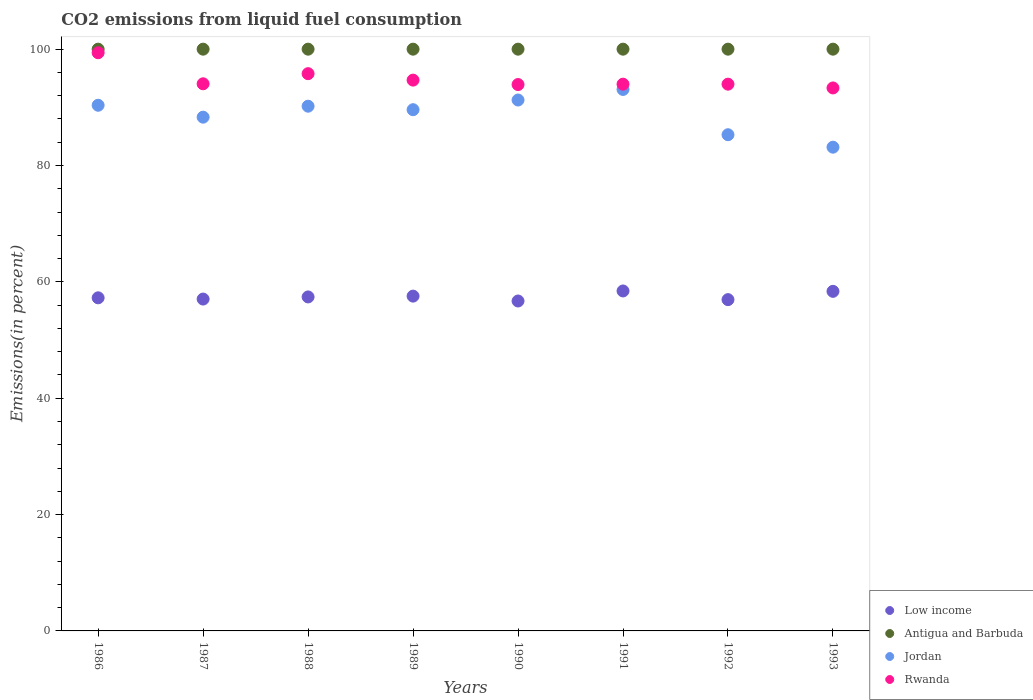What is the total CO2 emitted in Antigua and Barbuda in 1991?
Offer a terse response. 100. Across all years, what is the maximum total CO2 emitted in Antigua and Barbuda?
Give a very brief answer. 100. Across all years, what is the minimum total CO2 emitted in Jordan?
Offer a terse response. 83.15. In which year was the total CO2 emitted in Low income maximum?
Provide a succinct answer. 1991. What is the total total CO2 emitted in Rwanda in the graph?
Ensure brevity in your answer.  759.13. What is the difference between the total CO2 emitted in Antigua and Barbuda in 1992 and the total CO2 emitted in Low income in 1990?
Your answer should be very brief. 43.29. What is the average total CO2 emitted in Antigua and Barbuda per year?
Provide a short and direct response. 100. In the year 1993, what is the difference between the total CO2 emitted in Low income and total CO2 emitted in Antigua and Barbuda?
Provide a short and direct response. -41.63. In how many years, is the total CO2 emitted in Low income greater than 56 %?
Make the answer very short. 8. Is the total CO2 emitted in Antigua and Barbuda in 1987 less than that in 1993?
Give a very brief answer. No. Is the difference between the total CO2 emitted in Low income in 1986 and 1987 greater than the difference between the total CO2 emitted in Antigua and Barbuda in 1986 and 1987?
Offer a very short reply. Yes. What is the difference between the highest and the second highest total CO2 emitted in Jordan?
Your answer should be very brief. 1.82. What is the difference between the highest and the lowest total CO2 emitted in Jordan?
Your response must be concise. 9.92. In how many years, is the total CO2 emitted in Antigua and Barbuda greater than the average total CO2 emitted in Antigua and Barbuda taken over all years?
Make the answer very short. 0. Does the total CO2 emitted in Rwanda monotonically increase over the years?
Your answer should be compact. No. Is the total CO2 emitted in Jordan strictly less than the total CO2 emitted in Low income over the years?
Keep it short and to the point. No. How many dotlines are there?
Ensure brevity in your answer.  4. Are the values on the major ticks of Y-axis written in scientific E-notation?
Make the answer very short. No. Does the graph contain any zero values?
Ensure brevity in your answer.  No. Does the graph contain grids?
Provide a succinct answer. No. What is the title of the graph?
Your answer should be very brief. CO2 emissions from liquid fuel consumption. Does "Solomon Islands" appear as one of the legend labels in the graph?
Make the answer very short. No. What is the label or title of the X-axis?
Keep it short and to the point. Years. What is the label or title of the Y-axis?
Offer a terse response. Emissions(in percent). What is the Emissions(in percent) in Low income in 1986?
Your answer should be compact. 57.26. What is the Emissions(in percent) of Antigua and Barbuda in 1986?
Provide a short and direct response. 100. What is the Emissions(in percent) in Jordan in 1986?
Your answer should be very brief. 90.36. What is the Emissions(in percent) in Rwanda in 1986?
Make the answer very short. 99.39. What is the Emissions(in percent) of Low income in 1987?
Provide a succinct answer. 57.05. What is the Emissions(in percent) of Jordan in 1987?
Your answer should be compact. 88.31. What is the Emissions(in percent) of Rwanda in 1987?
Give a very brief answer. 94.05. What is the Emissions(in percent) of Low income in 1988?
Give a very brief answer. 57.41. What is the Emissions(in percent) of Jordan in 1988?
Your response must be concise. 90.2. What is the Emissions(in percent) of Rwanda in 1988?
Give a very brief answer. 95.79. What is the Emissions(in percent) of Low income in 1989?
Offer a very short reply. 57.55. What is the Emissions(in percent) of Antigua and Barbuda in 1989?
Keep it short and to the point. 100. What is the Emissions(in percent) of Jordan in 1989?
Provide a succinct answer. 89.59. What is the Emissions(in percent) of Rwanda in 1989?
Your response must be concise. 94.68. What is the Emissions(in percent) of Low income in 1990?
Your response must be concise. 56.71. What is the Emissions(in percent) in Jordan in 1990?
Give a very brief answer. 91.26. What is the Emissions(in percent) of Rwanda in 1990?
Offer a terse response. 93.92. What is the Emissions(in percent) in Low income in 1991?
Your answer should be compact. 58.44. What is the Emissions(in percent) in Antigua and Barbuda in 1991?
Offer a terse response. 100. What is the Emissions(in percent) of Jordan in 1991?
Make the answer very short. 93.08. What is the Emissions(in percent) in Rwanda in 1991?
Your answer should be very brief. 93.98. What is the Emissions(in percent) in Low income in 1992?
Your answer should be very brief. 56.95. What is the Emissions(in percent) of Jordan in 1992?
Provide a succinct answer. 85.29. What is the Emissions(in percent) in Rwanda in 1992?
Give a very brief answer. 93.98. What is the Emissions(in percent) of Low income in 1993?
Give a very brief answer. 58.37. What is the Emissions(in percent) in Jordan in 1993?
Ensure brevity in your answer.  83.15. What is the Emissions(in percent) of Rwanda in 1993?
Your answer should be compact. 93.33. Across all years, what is the maximum Emissions(in percent) of Low income?
Give a very brief answer. 58.44. Across all years, what is the maximum Emissions(in percent) in Antigua and Barbuda?
Provide a short and direct response. 100. Across all years, what is the maximum Emissions(in percent) in Jordan?
Keep it short and to the point. 93.08. Across all years, what is the maximum Emissions(in percent) of Rwanda?
Your answer should be very brief. 99.39. Across all years, what is the minimum Emissions(in percent) of Low income?
Keep it short and to the point. 56.71. Across all years, what is the minimum Emissions(in percent) in Antigua and Barbuda?
Your answer should be very brief. 100. Across all years, what is the minimum Emissions(in percent) in Jordan?
Your answer should be compact. 83.15. Across all years, what is the minimum Emissions(in percent) of Rwanda?
Make the answer very short. 93.33. What is the total Emissions(in percent) of Low income in the graph?
Make the answer very short. 459.73. What is the total Emissions(in percent) of Antigua and Barbuda in the graph?
Your answer should be very brief. 800. What is the total Emissions(in percent) of Jordan in the graph?
Your answer should be compact. 711.24. What is the total Emissions(in percent) in Rwanda in the graph?
Your answer should be very brief. 759.13. What is the difference between the Emissions(in percent) in Low income in 1986 and that in 1987?
Give a very brief answer. 0.21. What is the difference between the Emissions(in percent) of Antigua and Barbuda in 1986 and that in 1987?
Your response must be concise. 0. What is the difference between the Emissions(in percent) of Jordan in 1986 and that in 1987?
Give a very brief answer. 2.05. What is the difference between the Emissions(in percent) of Rwanda in 1986 and that in 1987?
Offer a terse response. 5.34. What is the difference between the Emissions(in percent) of Low income in 1986 and that in 1988?
Your response must be concise. -0.15. What is the difference between the Emissions(in percent) of Antigua and Barbuda in 1986 and that in 1988?
Provide a succinct answer. 0. What is the difference between the Emissions(in percent) of Jordan in 1986 and that in 1988?
Make the answer very short. 0.16. What is the difference between the Emissions(in percent) in Rwanda in 1986 and that in 1988?
Make the answer very short. 3.6. What is the difference between the Emissions(in percent) in Low income in 1986 and that in 1989?
Your answer should be compact. -0.29. What is the difference between the Emissions(in percent) in Antigua and Barbuda in 1986 and that in 1989?
Your response must be concise. 0. What is the difference between the Emissions(in percent) of Jordan in 1986 and that in 1989?
Your answer should be compact. 0.76. What is the difference between the Emissions(in percent) in Rwanda in 1986 and that in 1989?
Keep it short and to the point. 4.71. What is the difference between the Emissions(in percent) in Low income in 1986 and that in 1990?
Offer a terse response. 0.55. What is the difference between the Emissions(in percent) of Antigua and Barbuda in 1986 and that in 1990?
Make the answer very short. 0. What is the difference between the Emissions(in percent) of Jordan in 1986 and that in 1990?
Keep it short and to the point. -0.9. What is the difference between the Emissions(in percent) in Rwanda in 1986 and that in 1990?
Provide a succinct answer. 5.47. What is the difference between the Emissions(in percent) of Low income in 1986 and that in 1991?
Your response must be concise. -1.18. What is the difference between the Emissions(in percent) in Jordan in 1986 and that in 1991?
Offer a very short reply. -2.72. What is the difference between the Emissions(in percent) of Rwanda in 1986 and that in 1991?
Keep it short and to the point. 5.4. What is the difference between the Emissions(in percent) in Low income in 1986 and that in 1992?
Make the answer very short. 0.31. What is the difference between the Emissions(in percent) in Antigua and Barbuda in 1986 and that in 1992?
Your answer should be compact. 0. What is the difference between the Emissions(in percent) of Jordan in 1986 and that in 1992?
Make the answer very short. 5.07. What is the difference between the Emissions(in percent) of Rwanda in 1986 and that in 1992?
Offer a very short reply. 5.4. What is the difference between the Emissions(in percent) of Low income in 1986 and that in 1993?
Ensure brevity in your answer.  -1.11. What is the difference between the Emissions(in percent) in Jordan in 1986 and that in 1993?
Keep it short and to the point. 7.21. What is the difference between the Emissions(in percent) in Rwanda in 1986 and that in 1993?
Ensure brevity in your answer.  6.05. What is the difference between the Emissions(in percent) of Low income in 1987 and that in 1988?
Offer a very short reply. -0.37. What is the difference between the Emissions(in percent) in Jordan in 1987 and that in 1988?
Ensure brevity in your answer.  -1.89. What is the difference between the Emissions(in percent) in Rwanda in 1987 and that in 1988?
Ensure brevity in your answer.  -1.74. What is the difference between the Emissions(in percent) in Low income in 1987 and that in 1989?
Your answer should be compact. -0.51. What is the difference between the Emissions(in percent) of Antigua and Barbuda in 1987 and that in 1989?
Your response must be concise. 0. What is the difference between the Emissions(in percent) in Jordan in 1987 and that in 1989?
Your answer should be compact. -1.28. What is the difference between the Emissions(in percent) of Rwanda in 1987 and that in 1989?
Your answer should be compact. -0.63. What is the difference between the Emissions(in percent) in Low income in 1987 and that in 1990?
Give a very brief answer. 0.33. What is the difference between the Emissions(in percent) in Jordan in 1987 and that in 1990?
Make the answer very short. -2.95. What is the difference between the Emissions(in percent) in Rwanda in 1987 and that in 1990?
Give a very brief answer. 0.13. What is the difference between the Emissions(in percent) in Low income in 1987 and that in 1991?
Keep it short and to the point. -1.39. What is the difference between the Emissions(in percent) in Antigua and Barbuda in 1987 and that in 1991?
Provide a short and direct response. 0. What is the difference between the Emissions(in percent) in Jordan in 1987 and that in 1991?
Your answer should be very brief. -4.77. What is the difference between the Emissions(in percent) of Rwanda in 1987 and that in 1991?
Make the answer very short. 0.06. What is the difference between the Emissions(in percent) in Low income in 1987 and that in 1992?
Give a very brief answer. 0.1. What is the difference between the Emissions(in percent) in Jordan in 1987 and that in 1992?
Your answer should be very brief. 3.02. What is the difference between the Emissions(in percent) of Rwanda in 1987 and that in 1992?
Provide a short and direct response. 0.06. What is the difference between the Emissions(in percent) of Low income in 1987 and that in 1993?
Provide a short and direct response. -1.33. What is the difference between the Emissions(in percent) of Jordan in 1987 and that in 1993?
Make the answer very short. 5.16. What is the difference between the Emissions(in percent) of Rwanda in 1987 and that in 1993?
Your response must be concise. 0.71. What is the difference between the Emissions(in percent) in Low income in 1988 and that in 1989?
Your response must be concise. -0.14. What is the difference between the Emissions(in percent) in Jordan in 1988 and that in 1989?
Provide a short and direct response. 0.6. What is the difference between the Emissions(in percent) in Rwanda in 1988 and that in 1989?
Give a very brief answer. 1.11. What is the difference between the Emissions(in percent) of Low income in 1988 and that in 1990?
Keep it short and to the point. 0.7. What is the difference between the Emissions(in percent) in Antigua and Barbuda in 1988 and that in 1990?
Your answer should be compact. 0. What is the difference between the Emissions(in percent) of Jordan in 1988 and that in 1990?
Provide a short and direct response. -1.06. What is the difference between the Emissions(in percent) in Rwanda in 1988 and that in 1990?
Provide a short and direct response. 1.87. What is the difference between the Emissions(in percent) in Low income in 1988 and that in 1991?
Your answer should be very brief. -1.03. What is the difference between the Emissions(in percent) in Antigua and Barbuda in 1988 and that in 1991?
Ensure brevity in your answer.  0. What is the difference between the Emissions(in percent) of Jordan in 1988 and that in 1991?
Provide a succinct answer. -2.88. What is the difference between the Emissions(in percent) in Rwanda in 1988 and that in 1991?
Offer a terse response. 1.8. What is the difference between the Emissions(in percent) of Low income in 1988 and that in 1992?
Your answer should be very brief. 0.47. What is the difference between the Emissions(in percent) in Jordan in 1988 and that in 1992?
Provide a short and direct response. 4.91. What is the difference between the Emissions(in percent) in Rwanda in 1988 and that in 1992?
Keep it short and to the point. 1.8. What is the difference between the Emissions(in percent) of Low income in 1988 and that in 1993?
Your response must be concise. -0.96. What is the difference between the Emissions(in percent) in Antigua and Barbuda in 1988 and that in 1993?
Your answer should be very brief. 0. What is the difference between the Emissions(in percent) of Jordan in 1988 and that in 1993?
Make the answer very short. 7.05. What is the difference between the Emissions(in percent) of Rwanda in 1988 and that in 1993?
Keep it short and to the point. 2.46. What is the difference between the Emissions(in percent) of Low income in 1989 and that in 1990?
Keep it short and to the point. 0.84. What is the difference between the Emissions(in percent) in Jordan in 1989 and that in 1990?
Your answer should be compact. -1.66. What is the difference between the Emissions(in percent) of Rwanda in 1989 and that in 1990?
Your response must be concise. 0.76. What is the difference between the Emissions(in percent) in Low income in 1989 and that in 1991?
Keep it short and to the point. -0.89. What is the difference between the Emissions(in percent) in Jordan in 1989 and that in 1991?
Ensure brevity in your answer.  -3.48. What is the difference between the Emissions(in percent) in Rwanda in 1989 and that in 1991?
Keep it short and to the point. 0.7. What is the difference between the Emissions(in percent) in Low income in 1989 and that in 1992?
Provide a short and direct response. 0.6. What is the difference between the Emissions(in percent) in Antigua and Barbuda in 1989 and that in 1992?
Provide a succinct answer. 0. What is the difference between the Emissions(in percent) in Jordan in 1989 and that in 1992?
Provide a succinct answer. 4.3. What is the difference between the Emissions(in percent) of Rwanda in 1989 and that in 1992?
Your answer should be compact. 0.7. What is the difference between the Emissions(in percent) of Low income in 1989 and that in 1993?
Make the answer very short. -0.82. What is the difference between the Emissions(in percent) in Antigua and Barbuda in 1989 and that in 1993?
Ensure brevity in your answer.  0. What is the difference between the Emissions(in percent) in Jordan in 1989 and that in 1993?
Your response must be concise. 6.44. What is the difference between the Emissions(in percent) in Rwanda in 1989 and that in 1993?
Your answer should be very brief. 1.35. What is the difference between the Emissions(in percent) of Low income in 1990 and that in 1991?
Make the answer very short. -1.73. What is the difference between the Emissions(in percent) of Antigua and Barbuda in 1990 and that in 1991?
Your answer should be compact. 0. What is the difference between the Emissions(in percent) in Jordan in 1990 and that in 1991?
Your answer should be compact. -1.82. What is the difference between the Emissions(in percent) of Rwanda in 1990 and that in 1991?
Your answer should be very brief. -0.07. What is the difference between the Emissions(in percent) of Low income in 1990 and that in 1992?
Give a very brief answer. -0.23. What is the difference between the Emissions(in percent) in Antigua and Barbuda in 1990 and that in 1992?
Ensure brevity in your answer.  0. What is the difference between the Emissions(in percent) in Jordan in 1990 and that in 1992?
Provide a succinct answer. 5.97. What is the difference between the Emissions(in percent) in Rwanda in 1990 and that in 1992?
Provide a short and direct response. -0.07. What is the difference between the Emissions(in percent) of Low income in 1990 and that in 1993?
Your response must be concise. -1.66. What is the difference between the Emissions(in percent) in Antigua and Barbuda in 1990 and that in 1993?
Ensure brevity in your answer.  0. What is the difference between the Emissions(in percent) of Jordan in 1990 and that in 1993?
Your answer should be compact. 8.11. What is the difference between the Emissions(in percent) of Rwanda in 1990 and that in 1993?
Keep it short and to the point. 0.59. What is the difference between the Emissions(in percent) in Low income in 1991 and that in 1992?
Provide a short and direct response. 1.49. What is the difference between the Emissions(in percent) of Antigua and Barbuda in 1991 and that in 1992?
Ensure brevity in your answer.  0. What is the difference between the Emissions(in percent) in Jordan in 1991 and that in 1992?
Offer a very short reply. 7.78. What is the difference between the Emissions(in percent) in Rwanda in 1991 and that in 1992?
Ensure brevity in your answer.  0. What is the difference between the Emissions(in percent) of Low income in 1991 and that in 1993?
Give a very brief answer. 0.07. What is the difference between the Emissions(in percent) in Antigua and Barbuda in 1991 and that in 1993?
Your answer should be compact. 0. What is the difference between the Emissions(in percent) of Jordan in 1991 and that in 1993?
Your response must be concise. 9.92. What is the difference between the Emissions(in percent) of Rwanda in 1991 and that in 1993?
Make the answer very short. 0.65. What is the difference between the Emissions(in percent) in Low income in 1992 and that in 1993?
Your answer should be very brief. -1.43. What is the difference between the Emissions(in percent) in Jordan in 1992 and that in 1993?
Provide a short and direct response. 2.14. What is the difference between the Emissions(in percent) of Rwanda in 1992 and that in 1993?
Your answer should be very brief. 0.65. What is the difference between the Emissions(in percent) of Low income in 1986 and the Emissions(in percent) of Antigua and Barbuda in 1987?
Ensure brevity in your answer.  -42.74. What is the difference between the Emissions(in percent) of Low income in 1986 and the Emissions(in percent) of Jordan in 1987?
Offer a terse response. -31.05. What is the difference between the Emissions(in percent) of Low income in 1986 and the Emissions(in percent) of Rwanda in 1987?
Provide a short and direct response. -36.79. What is the difference between the Emissions(in percent) in Antigua and Barbuda in 1986 and the Emissions(in percent) in Jordan in 1987?
Make the answer very short. 11.69. What is the difference between the Emissions(in percent) of Antigua and Barbuda in 1986 and the Emissions(in percent) of Rwanda in 1987?
Provide a short and direct response. 5.95. What is the difference between the Emissions(in percent) in Jordan in 1986 and the Emissions(in percent) in Rwanda in 1987?
Your response must be concise. -3.69. What is the difference between the Emissions(in percent) of Low income in 1986 and the Emissions(in percent) of Antigua and Barbuda in 1988?
Provide a short and direct response. -42.74. What is the difference between the Emissions(in percent) of Low income in 1986 and the Emissions(in percent) of Jordan in 1988?
Your answer should be compact. -32.94. What is the difference between the Emissions(in percent) of Low income in 1986 and the Emissions(in percent) of Rwanda in 1988?
Your answer should be very brief. -38.53. What is the difference between the Emissions(in percent) in Antigua and Barbuda in 1986 and the Emissions(in percent) in Jordan in 1988?
Your answer should be very brief. 9.8. What is the difference between the Emissions(in percent) of Antigua and Barbuda in 1986 and the Emissions(in percent) of Rwanda in 1988?
Offer a terse response. 4.21. What is the difference between the Emissions(in percent) of Jordan in 1986 and the Emissions(in percent) of Rwanda in 1988?
Your answer should be compact. -5.43. What is the difference between the Emissions(in percent) of Low income in 1986 and the Emissions(in percent) of Antigua and Barbuda in 1989?
Offer a very short reply. -42.74. What is the difference between the Emissions(in percent) of Low income in 1986 and the Emissions(in percent) of Jordan in 1989?
Your answer should be compact. -32.34. What is the difference between the Emissions(in percent) in Low income in 1986 and the Emissions(in percent) in Rwanda in 1989?
Provide a succinct answer. -37.42. What is the difference between the Emissions(in percent) in Antigua and Barbuda in 1986 and the Emissions(in percent) in Jordan in 1989?
Provide a succinct answer. 10.41. What is the difference between the Emissions(in percent) of Antigua and Barbuda in 1986 and the Emissions(in percent) of Rwanda in 1989?
Offer a very short reply. 5.32. What is the difference between the Emissions(in percent) in Jordan in 1986 and the Emissions(in percent) in Rwanda in 1989?
Give a very brief answer. -4.32. What is the difference between the Emissions(in percent) of Low income in 1986 and the Emissions(in percent) of Antigua and Barbuda in 1990?
Your answer should be compact. -42.74. What is the difference between the Emissions(in percent) in Low income in 1986 and the Emissions(in percent) in Jordan in 1990?
Your response must be concise. -34. What is the difference between the Emissions(in percent) of Low income in 1986 and the Emissions(in percent) of Rwanda in 1990?
Your answer should be compact. -36.66. What is the difference between the Emissions(in percent) of Antigua and Barbuda in 1986 and the Emissions(in percent) of Jordan in 1990?
Give a very brief answer. 8.74. What is the difference between the Emissions(in percent) of Antigua and Barbuda in 1986 and the Emissions(in percent) of Rwanda in 1990?
Your response must be concise. 6.08. What is the difference between the Emissions(in percent) of Jordan in 1986 and the Emissions(in percent) of Rwanda in 1990?
Provide a short and direct response. -3.56. What is the difference between the Emissions(in percent) of Low income in 1986 and the Emissions(in percent) of Antigua and Barbuda in 1991?
Provide a short and direct response. -42.74. What is the difference between the Emissions(in percent) in Low income in 1986 and the Emissions(in percent) in Jordan in 1991?
Offer a terse response. -35.82. What is the difference between the Emissions(in percent) in Low income in 1986 and the Emissions(in percent) in Rwanda in 1991?
Provide a short and direct response. -36.73. What is the difference between the Emissions(in percent) of Antigua and Barbuda in 1986 and the Emissions(in percent) of Jordan in 1991?
Provide a short and direct response. 6.92. What is the difference between the Emissions(in percent) of Antigua and Barbuda in 1986 and the Emissions(in percent) of Rwanda in 1991?
Offer a very short reply. 6.01. What is the difference between the Emissions(in percent) of Jordan in 1986 and the Emissions(in percent) of Rwanda in 1991?
Ensure brevity in your answer.  -3.63. What is the difference between the Emissions(in percent) in Low income in 1986 and the Emissions(in percent) in Antigua and Barbuda in 1992?
Give a very brief answer. -42.74. What is the difference between the Emissions(in percent) of Low income in 1986 and the Emissions(in percent) of Jordan in 1992?
Offer a terse response. -28.03. What is the difference between the Emissions(in percent) in Low income in 1986 and the Emissions(in percent) in Rwanda in 1992?
Give a very brief answer. -36.73. What is the difference between the Emissions(in percent) in Antigua and Barbuda in 1986 and the Emissions(in percent) in Jordan in 1992?
Provide a succinct answer. 14.71. What is the difference between the Emissions(in percent) in Antigua and Barbuda in 1986 and the Emissions(in percent) in Rwanda in 1992?
Keep it short and to the point. 6.01. What is the difference between the Emissions(in percent) in Jordan in 1986 and the Emissions(in percent) in Rwanda in 1992?
Keep it short and to the point. -3.63. What is the difference between the Emissions(in percent) in Low income in 1986 and the Emissions(in percent) in Antigua and Barbuda in 1993?
Keep it short and to the point. -42.74. What is the difference between the Emissions(in percent) of Low income in 1986 and the Emissions(in percent) of Jordan in 1993?
Ensure brevity in your answer.  -25.89. What is the difference between the Emissions(in percent) of Low income in 1986 and the Emissions(in percent) of Rwanda in 1993?
Ensure brevity in your answer.  -36.08. What is the difference between the Emissions(in percent) in Antigua and Barbuda in 1986 and the Emissions(in percent) in Jordan in 1993?
Your answer should be very brief. 16.85. What is the difference between the Emissions(in percent) of Jordan in 1986 and the Emissions(in percent) of Rwanda in 1993?
Ensure brevity in your answer.  -2.97. What is the difference between the Emissions(in percent) of Low income in 1987 and the Emissions(in percent) of Antigua and Barbuda in 1988?
Ensure brevity in your answer.  -42.95. What is the difference between the Emissions(in percent) in Low income in 1987 and the Emissions(in percent) in Jordan in 1988?
Give a very brief answer. -33.15. What is the difference between the Emissions(in percent) in Low income in 1987 and the Emissions(in percent) in Rwanda in 1988?
Provide a succinct answer. -38.74. What is the difference between the Emissions(in percent) in Antigua and Barbuda in 1987 and the Emissions(in percent) in Jordan in 1988?
Provide a short and direct response. 9.8. What is the difference between the Emissions(in percent) in Antigua and Barbuda in 1987 and the Emissions(in percent) in Rwanda in 1988?
Make the answer very short. 4.21. What is the difference between the Emissions(in percent) in Jordan in 1987 and the Emissions(in percent) in Rwanda in 1988?
Keep it short and to the point. -7.48. What is the difference between the Emissions(in percent) in Low income in 1987 and the Emissions(in percent) in Antigua and Barbuda in 1989?
Make the answer very short. -42.95. What is the difference between the Emissions(in percent) in Low income in 1987 and the Emissions(in percent) in Jordan in 1989?
Offer a very short reply. -32.55. What is the difference between the Emissions(in percent) in Low income in 1987 and the Emissions(in percent) in Rwanda in 1989?
Your answer should be very brief. -37.64. What is the difference between the Emissions(in percent) of Antigua and Barbuda in 1987 and the Emissions(in percent) of Jordan in 1989?
Your response must be concise. 10.41. What is the difference between the Emissions(in percent) in Antigua and Barbuda in 1987 and the Emissions(in percent) in Rwanda in 1989?
Your answer should be compact. 5.32. What is the difference between the Emissions(in percent) in Jordan in 1987 and the Emissions(in percent) in Rwanda in 1989?
Your answer should be very brief. -6.37. What is the difference between the Emissions(in percent) in Low income in 1987 and the Emissions(in percent) in Antigua and Barbuda in 1990?
Offer a terse response. -42.95. What is the difference between the Emissions(in percent) in Low income in 1987 and the Emissions(in percent) in Jordan in 1990?
Offer a terse response. -34.21. What is the difference between the Emissions(in percent) of Low income in 1987 and the Emissions(in percent) of Rwanda in 1990?
Make the answer very short. -36.87. What is the difference between the Emissions(in percent) in Antigua and Barbuda in 1987 and the Emissions(in percent) in Jordan in 1990?
Keep it short and to the point. 8.74. What is the difference between the Emissions(in percent) of Antigua and Barbuda in 1987 and the Emissions(in percent) of Rwanda in 1990?
Keep it short and to the point. 6.08. What is the difference between the Emissions(in percent) of Jordan in 1987 and the Emissions(in percent) of Rwanda in 1990?
Offer a terse response. -5.61. What is the difference between the Emissions(in percent) in Low income in 1987 and the Emissions(in percent) in Antigua and Barbuda in 1991?
Provide a short and direct response. -42.95. What is the difference between the Emissions(in percent) of Low income in 1987 and the Emissions(in percent) of Jordan in 1991?
Offer a terse response. -36.03. What is the difference between the Emissions(in percent) of Low income in 1987 and the Emissions(in percent) of Rwanda in 1991?
Provide a short and direct response. -36.94. What is the difference between the Emissions(in percent) in Antigua and Barbuda in 1987 and the Emissions(in percent) in Jordan in 1991?
Provide a succinct answer. 6.92. What is the difference between the Emissions(in percent) in Antigua and Barbuda in 1987 and the Emissions(in percent) in Rwanda in 1991?
Provide a short and direct response. 6.01. What is the difference between the Emissions(in percent) in Jordan in 1987 and the Emissions(in percent) in Rwanda in 1991?
Keep it short and to the point. -5.67. What is the difference between the Emissions(in percent) in Low income in 1987 and the Emissions(in percent) in Antigua and Barbuda in 1992?
Keep it short and to the point. -42.95. What is the difference between the Emissions(in percent) of Low income in 1987 and the Emissions(in percent) of Jordan in 1992?
Give a very brief answer. -28.25. What is the difference between the Emissions(in percent) in Low income in 1987 and the Emissions(in percent) in Rwanda in 1992?
Your response must be concise. -36.94. What is the difference between the Emissions(in percent) of Antigua and Barbuda in 1987 and the Emissions(in percent) of Jordan in 1992?
Keep it short and to the point. 14.71. What is the difference between the Emissions(in percent) of Antigua and Barbuda in 1987 and the Emissions(in percent) of Rwanda in 1992?
Offer a terse response. 6.01. What is the difference between the Emissions(in percent) in Jordan in 1987 and the Emissions(in percent) in Rwanda in 1992?
Keep it short and to the point. -5.67. What is the difference between the Emissions(in percent) in Low income in 1987 and the Emissions(in percent) in Antigua and Barbuda in 1993?
Provide a short and direct response. -42.95. What is the difference between the Emissions(in percent) in Low income in 1987 and the Emissions(in percent) in Jordan in 1993?
Provide a succinct answer. -26.11. What is the difference between the Emissions(in percent) in Low income in 1987 and the Emissions(in percent) in Rwanda in 1993?
Your response must be concise. -36.29. What is the difference between the Emissions(in percent) in Antigua and Barbuda in 1987 and the Emissions(in percent) in Jordan in 1993?
Offer a terse response. 16.85. What is the difference between the Emissions(in percent) in Antigua and Barbuda in 1987 and the Emissions(in percent) in Rwanda in 1993?
Your answer should be compact. 6.67. What is the difference between the Emissions(in percent) in Jordan in 1987 and the Emissions(in percent) in Rwanda in 1993?
Give a very brief answer. -5.02. What is the difference between the Emissions(in percent) of Low income in 1988 and the Emissions(in percent) of Antigua and Barbuda in 1989?
Offer a terse response. -42.59. What is the difference between the Emissions(in percent) of Low income in 1988 and the Emissions(in percent) of Jordan in 1989?
Your response must be concise. -32.18. What is the difference between the Emissions(in percent) of Low income in 1988 and the Emissions(in percent) of Rwanda in 1989?
Provide a short and direct response. -37.27. What is the difference between the Emissions(in percent) in Antigua and Barbuda in 1988 and the Emissions(in percent) in Jordan in 1989?
Your response must be concise. 10.41. What is the difference between the Emissions(in percent) in Antigua and Barbuda in 1988 and the Emissions(in percent) in Rwanda in 1989?
Provide a succinct answer. 5.32. What is the difference between the Emissions(in percent) in Jordan in 1988 and the Emissions(in percent) in Rwanda in 1989?
Make the answer very short. -4.48. What is the difference between the Emissions(in percent) of Low income in 1988 and the Emissions(in percent) of Antigua and Barbuda in 1990?
Offer a very short reply. -42.59. What is the difference between the Emissions(in percent) of Low income in 1988 and the Emissions(in percent) of Jordan in 1990?
Provide a short and direct response. -33.85. What is the difference between the Emissions(in percent) in Low income in 1988 and the Emissions(in percent) in Rwanda in 1990?
Ensure brevity in your answer.  -36.51. What is the difference between the Emissions(in percent) of Antigua and Barbuda in 1988 and the Emissions(in percent) of Jordan in 1990?
Offer a terse response. 8.74. What is the difference between the Emissions(in percent) in Antigua and Barbuda in 1988 and the Emissions(in percent) in Rwanda in 1990?
Ensure brevity in your answer.  6.08. What is the difference between the Emissions(in percent) in Jordan in 1988 and the Emissions(in percent) in Rwanda in 1990?
Your answer should be compact. -3.72. What is the difference between the Emissions(in percent) of Low income in 1988 and the Emissions(in percent) of Antigua and Barbuda in 1991?
Your answer should be compact. -42.59. What is the difference between the Emissions(in percent) of Low income in 1988 and the Emissions(in percent) of Jordan in 1991?
Your answer should be very brief. -35.66. What is the difference between the Emissions(in percent) of Low income in 1988 and the Emissions(in percent) of Rwanda in 1991?
Provide a short and direct response. -36.57. What is the difference between the Emissions(in percent) in Antigua and Barbuda in 1988 and the Emissions(in percent) in Jordan in 1991?
Your answer should be very brief. 6.92. What is the difference between the Emissions(in percent) of Antigua and Barbuda in 1988 and the Emissions(in percent) of Rwanda in 1991?
Your response must be concise. 6.01. What is the difference between the Emissions(in percent) in Jordan in 1988 and the Emissions(in percent) in Rwanda in 1991?
Keep it short and to the point. -3.79. What is the difference between the Emissions(in percent) of Low income in 1988 and the Emissions(in percent) of Antigua and Barbuda in 1992?
Give a very brief answer. -42.59. What is the difference between the Emissions(in percent) of Low income in 1988 and the Emissions(in percent) of Jordan in 1992?
Your answer should be compact. -27.88. What is the difference between the Emissions(in percent) of Low income in 1988 and the Emissions(in percent) of Rwanda in 1992?
Offer a very short reply. -36.57. What is the difference between the Emissions(in percent) of Antigua and Barbuda in 1988 and the Emissions(in percent) of Jordan in 1992?
Provide a succinct answer. 14.71. What is the difference between the Emissions(in percent) of Antigua and Barbuda in 1988 and the Emissions(in percent) of Rwanda in 1992?
Your answer should be compact. 6.01. What is the difference between the Emissions(in percent) of Jordan in 1988 and the Emissions(in percent) of Rwanda in 1992?
Your response must be concise. -3.79. What is the difference between the Emissions(in percent) of Low income in 1988 and the Emissions(in percent) of Antigua and Barbuda in 1993?
Keep it short and to the point. -42.59. What is the difference between the Emissions(in percent) in Low income in 1988 and the Emissions(in percent) in Jordan in 1993?
Offer a very short reply. -25.74. What is the difference between the Emissions(in percent) in Low income in 1988 and the Emissions(in percent) in Rwanda in 1993?
Offer a very short reply. -35.92. What is the difference between the Emissions(in percent) of Antigua and Barbuda in 1988 and the Emissions(in percent) of Jordan in 1993?
Provide a succinct answer. 16.85. What is the difference between the Emissions(in percent) of Antigua and Barbuda in 1988 and the Emissions(in percent) of Rwanda in 1993?
Offer a very short reply. 6.67. What is the difference between the Emissions(in percent) in Jordan in 1988 and the Emissions(in percent) in Rwanda in 1993?
Make the answer very short. -3.14. What is the difference between the Emissions(in percent) of Low income in 1989 and the Emissions(in percent) of Antigua and Barbuda in 1990?
Your answer should be very brief. -42.45. What is the difference between the Emissions(in percent) in Low income in 1989 and the Emissions(in percent) in Jordan in 1990?
Your answer should be compact. -33.71. What is the difference between the Emissions(in percent) in Low income in 1989 and the Emissions(in percent) in Rwanda in 1990?
Offer a very short reply. -36.37. What is the difference between the Emissions(in percent) in Antigua and Barbuda in 1989 and the Emissions(in percent) in Jordan in 1990?
Offer a very short reply. 8.74. What is the difference between the Emissions(in percent) in Antigua and Barbuda in 1989 and the Emissions(in percent) in Rwanda in 1990?
Your answer should be very brief. 6.08. What is the difference between the Emissions(in percent) of Jordan in 1989 and the Emissions(in percent) of Rwanda in 1990?
Keep it short and to the point. -4.32. What is the difference between the Emissions(in percent) of Low income in 1989 and the Emissions(in percent) of Antigua and Barbuda in 1991?
Provide a succinct answer. -42.45. What is the difference between the Emissions(in percent) of Low income in 1989 and the Emissions(in percent) of Jordan in 1991?
Provide a short and direct response. -35.53. What is the difference between the Emissions(in percent) in Low income in 1989 and the Emissions(in percent) in Rwanda in 1991?
Your response must be concise. -36.43. What is the difference between the Emissions(in percent) of Antigua and Barbuda in 1989 and the Emissions(in percent) of Jordan in 1991?
Your answer should be very brief. 6.92. What is the difference between the Emissions(in percent) of Antigua and Barbuda in 1989 and the Emissions(in percent) of Rwanda in 1991?
Make the answer very short. 6.01. What is the difference between the Emissions(in percent) in Jordan in 1989 and the Emissions(in percent) in Rwanda in 1991?
Provide a short and direct response. -4.39. What is the difference between the Emissions(in percent) of Low income in 1989 and the Emissions(in percent) of Antigua and Barbuda in 1992?
Provide a succinct answer. -42.45. What is the difference between the Emissions(in percent) in Low income in 1989 and the Emissions(in percent) in Jordan in 1992?
Provide a short and direct response. -27.74. What is the difference between the Emissions(in percent) in Low income in 1989 and the Emissions(in percent) in Rwanda in 1992?
Ensure brevity in your answer.  -36.43. What is the difference between the Emissions(in percent) of Antigua and Barbuda in 1989 and the Emissions(in percent) of Jordan in 1992?
Give a very brief answer. 14.71. What is the difference between the Emissions(in percent) of Antigua and Barbuda in 1989 and the Emissions(in percent) of Rwanda in 1992?
Give a very brief answer. 6.01. What is the difference between the Emissions(in percent) in Jordan in 1989 and the Emissions(in percent) in Rwanda in 1992?
Make the answer very short. -4.39. What is the difference between the Emissions(in percent) in Low income in 1989 and the Emissions(in percent) in Antigua and Barbuda in 1993?
Ensure brevity in your answer.  -42.45. What is the difference between the Emissions(in percent) of Low income in 1989 and the Emissions(in percent) of Jordan in 1993?
Your answer should be compact. -25.6. What is the difference between the Emissions(in percent) in Low income in 1989 and the Emissions(in percent) in Rwanda in 1993?
Provide a succinct answer. -35.78. What is the difference between the Emissions(in percent) of Antigua and Barbuda in 1989 and the Emissions(in percent) of Jordan in 1993?
Your response must be concise. 16.85. What is the difference between the Emissions(in percent) in Jordan in 1989 and the Emissions(in percent) in Rwanda in 1993?
Your answer should be very brief. -3.74. What is the difference between the Emissions(in percent) in Low income in 1990 and the Emissions(in percent) in Antigua and Barbuda in 1991?
Provide a succinct answer. -43.29. What is the difference between the Emissions(in percent) in Low income in 1990 and the Emissions(in percent) in Jordan in 1991?
Keep it short and to the point. -36.36. What is the difference between the Emissions(in percent) in Low income in 1990 and the Emissions(in percent) in Rwanda in 1991?
Ensure brevity in your answer.  -37.27. What is the difference between the Emissions(in percent) of Antigua and Barbuda in 1990 and the Emissions(in percent) of Jordan in 1991?
Your answer should be very brief. 6.92. What is the difference between the Emissions(in percent) of Antigua and Barbuda in 1990 and the Emissions(in percent) of Rwanda in 1991?
Offer a very short reply. 6.01. What is the difference between the Emissions(in percent) in Jordan in 1990 and the Emissions(in percent) in Rwanda in 1991?
Offer a terse response. -2.73. What is the difference between the Emissions(in percent) in Low income in 1990 and the Emissions(in percent) in Antigua and Barbuda in 1992?
Offer a very short reply. -43.29. What is the difference between the Emissions(in percent) of Low income in 1990 and the Emissions(in percent) of Jordan in 1992?
Your answer should be very brief. -28.58. What is the difference between the Emissions(in percent) of Low income in 1990 and the Emissions(in percent) of Rwanda in 1992?
Keep it short and to the point. -37.27. What is the difference between the Emissions(in percent) in Antigua and Barbuda in 1990 and the Emissions(in percent) in Jordan in 1992?
Provide a succinct answer. 14.71. What is the difference between the Emissions(in percent) of Antigua and Barbuda in 1990 and the Emissions(in percent) of Rwanda in 1992?
Provide a succinct answer. 6.01. What is the difference between the Emissions(in percent) of Jordan in 1990 and the Emissions(in percent) of Rwanda in 1992?
Provide a succinct answer. -2.73. What is the difference between the Emissions(in percent) in Low income in 1990 and the Emissions(in percent) in Antigua and Barbuda in 1993?
Offer a terse response. -43.29. What is the difference between the Emissions(in percent) in Low income in 1990 and the Emissions(in percent) in Jordan in 1993?
Your answer should be compact. -26.44. What is the difference between the Emissions(in percent) in Low income in 1990 and the Emissions(in percent) in Rwanda in 1993?
Your answer should be compact. -36.62. What is the difference between the Emissions(in percent) in Antigua and Barbuda in 1990 and the Emissions(in percent) in Jordan in 1993?
Keep it short and to the point. 16.85. What is the difference between the Emissions(in percent) in Jordan in 1990 and the Emissions(in percent) in Rwanda in 1993?
Provide a short and direct response. -2.08. What is the difference between the Emissions(in percent) of Low income in 1991 and the Emissions(in percent) of Antigua and Barbuda in 1992?
Keep it short and to the point. -41.56. What is the difference between the Emissions(in percent) of Low income in 1991 and the Emissions(in percent) of Jordan in 1992?
Give a very brief answer. -26.85. What is the difference between the Emissions(in percent) of Low income in 1991 and the Emissions(in percent) of Rwanda in 1992?
Provide a succinct answer. -35.55. What is the difference between the Emissions(in percent) in Antigua and Barbuda in 1991 and the Emissions(in percent) in Jordan in 1992?
Offer a terse response. 14.71. What is the difference between the Emissions(in percent) of Antigua and Barbuda in 1991 and the Emissions(in percent) of Rwanda in 1992?
Offer a very short reply. 6.01. What is the difference between the Emissions(in percent) in Jordan in 1991 and the Emissions(in percent) in Rwanda in 1992?
Provide a succinct answer. -0.91. What is the difference between the Emissions(in percent) of Low income in 1991 and the Emissions(in percent) of Antigua and Barbuda in 1993?
Ensure brevity in your answer.  -41.56. What is the difference between the Emissions(in percent) of Low income in 1991 and the Emissions(in percent) of Jordan in 1993?
Provide a succinct answer. -24.71. What is the difference between the Emissions(in percent) of Low income in 1991 and the Emissions(in percent) of Rwanda in 1993?
Your answer should be compact. -34.9. What is the difference between the Emissions(in percent) in Antigua and Barbuda in 1991 and the Emissions(in percent) in Jordan in 1993?
Make the answer very short. 16.85. What is the difference between the Emissions(in percent) in Antigua and Barbuda in 1991 and the Emissions(in percent) in Rwanda in 1993?
Ensure brevity in your answer.  6.67. What is the difference between the Emissions(in percent) of Jordan in 1991 and the Emissions(in percent) of Rwanda in 1993?
Your response must be concise. -0.26. What is the difference between the Emissions(in percent) in Low income in 1992 and the Emissions(in percent) in Antigua and Barbuda in 1993?
Offer a terse response. -43.05. What is the difference between the Emissions(in percent) of Low income in 1992 and the Emissions(in percent) of Jordan in 1993?
Ensure brevity in your answer.  -26.21. What is the difference between the Emissions(in percent) in Low income in 1992 and the Emissions(in percent) in Rwanda in 1993?
Your answer should be very brief. -36.39. What is the difference between the Emissions(in percent) of Antigua and Barbuda in 1992 and the Emissions(in percent) of Jordan in 1993?
Your answer should be compact. 16.85. What is the difference between the Emissions(in percent) of Jordan in 1992 and the Emissions(in percent) of Rwanda in 1993?
Provide a succinct answer. -8.04. What is the average Emissions(in percent) of Low income per year?
Your response must be concise. 57.47. What is the average Emissions(in percent) in Antigua and Barbuda per year?
Your answer should be very brief. 100. What is the average Emissions(in percent) in Jordan per year?
Offer a very short reply. 88.91. What is the average Emissions(in percent) in Rwanda per year?
Offer a very short reply. 94.89. In the year 1986, what is the difference between the Emissions(in percent) in Low income and Emissions(in percent) in Antigua and Barbuda?
Give a very brief answer. -42.74. In the year 1986, what is the difference between the Emissions(in percent) in Low income and Emissions(in percent) in Jordan?
Keep it short and to the point. -33.1. In the year 1986, what is the difference between the Emissions(in percent) in Low income and Emissions(in percent) in Rwanda?
Make the answer very short. -42.13. In the year 1986, what is the difference between the Emissions(in percent) of Antigua and Barbuda and Emissions(in percent) of Jordan?
Ensure brevity in your answer.  9.64. In the year 1986, what is the difference between the Emissions(in percent) in Antigua and Barbuda and Emissions(in percent) in Rwanda?
Your response must be concise. 0.61. In the year 1986, what is the difference between the Emissions(in percent) of Jordan and Emissions(in percent) of Rwanda?
Ensure brevity in your answer.  -9.03. In the year 1987, what is the difference between the Emissions(in percent) in Low income and Emissions(in percent) in Antigua and Barbuda?
Offer a terse response. -42.95. In the year 1987, what is the difference between the Emissions(in percent) of Low income and Emissions(in percent) of Jordan?
Ensure brevity in your answer.  -31.27. In the year 1987, what is the difference between the Emissions(in percent) of Low income and Emissions(in percent) of Rwanda?
Your answer should be very brief. -37. In the year 1987, what is the difference between the Emissions(in percent) of Antigua and Barbuda and Emissions(in percent) of Jordan?
Keep it short and to the point. 11.69. In the year 1987, what is the difference between the Emissions(in percent) in Antigua and Barbuda and Emissions(in percent) in Rwanda?
Make the answer very short. 5.95. In the year 1987, what is the difference between the Emissions(in percent) of Jordan and Emissions(in percent) of Rwanda?
Your answer should be compact. -5.74. In the year 1988, what is the difference between the Emissions(in percent) in Low income and Emissions(in percent) in Antigua and Barbuda?
Give a very brief answer. -42.59. In the year 1988, what is the difference between the Emissions(in percent) of Low income and Emissions(in percent) of Jordan?
Offer a terse response. -32.79. In the year 1988, what is the difference between the Emissions(in percent) in Low income and Emissions(in percent) in Rwanda?
Ensure brevity in your answer.  -38.38. In the year 1988, what is the difference between the Emissions(in percent) of Antigua and Barbuda and Emissions(in percent) of Jordan?
Give a very brief answer. 9.8. In the year 1988, what is the difference between the Emissions(in percent) of Antigua and Barbuda and Emissions(in percent) of Rwanda?
Ensure brevity in your answer.  4.21. In the year 1988, what is the difference between the Emissions(in percent) in Jordan and Emissions(in percent) in Rwanda?
Make the answer very short. -5.59. In the year 1989, what is the difference between the Emissions(in percent) in Low income and Emissions(in percent) in Antigua and Barbuda?
Give a very brief answer. -42.45. In the year 1989, what is the difference between the Emissions(in percent) of Low income and Emissions(in percent) of Jordan?
Make the answer very short. -32.04. In the year 1989, what is the difference between the Emissions(in percent) of Low income and Emissions(in percent) of Rwanda?
Ensure brevity in your answer.  -37.13. In the year 1989, what is the difference between the Emissions(in percent) in Antigua and Barbuda and Emissions(in percent) in Jordan?
Offer a very short reply. 10.41. In the year 1989, what is the difference between the Emissions(in percent) of Antigua and Barbuda and Emissions(in percent) of Rwanda?
Make the answer very short. 5.32. In the year 1989, what is the difference between the Emissions(in percent) in Jordan and Emissions(in percent) in Rwanda?
Your response must be concise. -5.09. In the year 1990, what is the difference between the Emissions(in percent) of Low income and Emissions(in percent) of Antigua and Barbuda?
Ensure brevity in your answer.  -43.29. In the year 1990, what is the difference between the Emissions(in percent) of Low income and Emissions(in percent) of Jordan?
Your response must be concise. -34.55. In the year 1990, what is the difference between the Emissions(in percent) in Low income and Emissions(in percent) in Rwanda?
Your answer should be compact. -37.21. In the year 1990, what is the difference between the Emissions(in percent) in Antigua and Barbuda and Emissions(in percent) in Jordan?
Ensure brevity in your answer.  8.74. In the year 1990, what is the difference between the Emissions(in percent) of Antigua and Barbuda and Emissions(in percent) of Rwanda?
Give a very brief answer. 6.08. In the year 1990, what is the difference between the Emissions(in percent) in Jordan and Emissions(in percent) in Rwanda?
Make the answer very short. -2.66. In the year 1991, what is the difference between the Emissions(in percent) of Low income and Emissions(in percent) of Antigua and Barbuda?
Your response must be concise. -41.56. In the year 1991, what is the difference between the Emissions(in percent) of Low income and Emissions(in percent) of Jordan?
Your answer should be compact. -34.64. In the year 1991, what is the difference between the Emissions(in percent) of Low income and Emissions(in percent) of Rwanda?
Your answer should be very brief. -35.55. In the year 1991, what is the difference between the Emissions(in percent) of Antigua and Barbuda and Emissions(in percent) of Jordan?
Give a very brief answer. 6.92. In the year 1991, what is the difference between the Emissions(in percent) in Antigua and Barbuda and Emissions(in percent) in Rwanda?
Make the answer very short. 6.01. In the year 1991, what is the difference between the Emissions(in percent) in Jordan and Emissions(in percent) in Rwanda?
Provide a short and direct response. -0.91. In the year 1992, what is the difference between the Emissions(in percent) in Low income and Emissions(in percent) in Antigua and Barbuda?
Ensure brevity in your answer.  -43.05. In the year 1992, what is the difference between the Emissions(in percent) of Low income and Emissions(in percent) of Jordan?
Your answer should be compact. -28.35. In the year 1992, what is the difference between the Emissions(in percent) in Low income and Emissions(in percent) in Rwanda?
Your answer should be very brief. -37.04. In the year 1992, what is the difference between the Emissions(in percent) in Antigua and Barbuda and Emissions(in percent) in Jordan?
Provide a short and direct response. 14.71. In the year 1992, what is the difference between the Emissions(in percent) of Antigua and Barbuda and Emissions(in percent) of Rwanda?
Offer a terse response. 6.01. In the year 1992, what is the difference between the Emissions(in percent) in Jordan and Emissions(in percent) in Rwanda?
Offer a very short reply. -8.69. In the year 1993, what is the difference between the Emissions(in percent) of Low income and Emissions(in percent) of Antigua and Barbuda?
Offer a terse response. -41.63. In the year 1993, what is the difference between the Emissions(in percent) in Low income and Emissions(in percent) in Jordan?
Provide a succinct answer. -24.78. In the year 1993, what is the difference between the Emissions(in percent) in Low income and Emissions(in percent) in Rwanda?
Your answer should be very brief. -34.96. In the year 1993, what is the difference between the Emissions(in percent) of Antigua and Barbuda and Emissions(in percent) of Jordan?
Make the answer very short. 16.85. In the year 1993, what is the difference between the Emissions(in percent) of Jordan and Emissions(in percent) of Rwanda?
Provide a short and direct response. -10.18. What is the ratio of the Emissions(in percent) in Antigua and Barbuda in 1986 to that in 1987?
Provide a short and direct response. 1. What is the ratio of the Emissions(in percent) of Jordan in 1986 to that in 1987?
Provide a short and direct response. 1.02. What is the ratio of the Emissions(in percent) of Rwanda in 1986 to that in 1987?
Provide a succinct answer. 1.06. What is the ratio of the Emissions(in percent) in Jordan in 1986 to that in 1988?
Keep it short and to the point. 1. What is the ratio of the Emissions(in percent) in Rwanda in 1986 to that in 1988?
Your answer should be very brief. 1.04. What is the ratio of the Emissions(in percent) of Low income in 1986 to that in 1989?
Your response must be concise. 0.99. What is the ratio of the Emissions(in percent) in Antigua and Barbuda in 1986 to that in 1989?
Offer a terse response. 1. What is the ratio of the Emissions(in percent) in Jordan in 1986 to that in 1989?
Give a very brief answer. 1.01. What is the ratio of the Emissions(in percent) in Rwanda in 1986 to that in 1989?
Offer a very short reply. 1.05. What is the ratio of the Emissions(in percent) in Low income in 1986 to that in 1990?
Your response must be concise. 1.01. What is the ratio of the Emissions(in percent) in Antigua and Barbuda in 1986 to that in 1990?
Your response must be concise. 1. What is the ratio of the Emissions(in percent) in Jordan in 1986 to that in 1990?
Ensure brevity in your answer.  0.99. What is the ratio of the Emissions(in percent) of Rwanda in 1986 to that in 1990?
Make the answer very short. 1.06. What is the ratio of the Emissions(in percent) in Low income in 1986 to that in 1991?
Offer a very short reply. 0.98. What is the ratio of the Emissions(in percent) in Antigua and Barbuda in 1986 to that in 1991?
Make the answer very short. 1. What is the ratio of the Emissions(in percent) in Jordan in 1986 to that in 1991?
Provide a short and direct response. 0.97. What is the ratio of the Emissions(in percent) in Rwanda in 1986 to that in 1991?
Ensure brevity in your answer.  1.06. What is the ratio of the Emissions(in percent) of Jordan in 1986 to that in 1992?
Provide a succinct answer. 1.06. What is the ratio of the Emissions(in percent) of Rwanda in 1986 to that in 1992?
Your answer should be compact. 1.06. What is the ratio of the Emissions(in percent) of Low income in 1986 to that in 1993?
Your response must be concise. 0.98. What is the ratio of the Emissions(in percent) in Jordan in 1986 to that in 1993?
Provide a succinct answer. 1.09. What is the ratio of the Emissions(in percent) of Rwanda in 1986 to that in 1993?
Provide a short and direct response. 1.06. What is the ratio of the Emissions(in percent) in Antigua and Barbuda in 1987 to that in 1988?
Offer a very short reply. 1. What is the ratio of the Emissions(in percent) of Jordan in 1987 to that in 1988?
Provide a short and direct response. 0.98. What is the ratio of the Emissions(in percent) in Rwanda in 1987 to that in 1988?
Make the answer very short. 0.98. What is the ratio of the Emissions(in percent) in Low income in 1987 to that in 1989?
Your answer should be very brief. 0.99. What is the ratio of the Emissions(in percent) in Antigua and Barbuda in 1987 to that in 1989?
Your answer should be compact. 1. What is the ratio of the Emissions(in percent) in Jordan in 1987 to that in 1989?
Provide a succinct answer. 0.99. What is the ratio of the Emissions(in percent) in Rwanda in 1987 to that in 1989?
Ensure brevity in your answer.  0.99. What is the ratio of the Emissions(in percent) of Low income in 1987 to that in 1990?
Offer a very short reply. 1.01. What is the ratio of the Emissions(in percent) of Rwanda in 1987 to that in 1990?
Provide a short and direct response. 1. What is the ratio of the Emissions(in percent) in Low income in 1987 to that in 1991?
Provide a succinct answer. 0.98. What is the ratio of the Emissions(in percent) of Antigua and Barbuda in 1987 to that in 1991?
Provide a short and direct response. 1. What is the ratio of the Emissions(in percent) of Jordan in 1987 to that in 1991?
Provide a short and direct response. 0.95. What is the ratio of the Emissions(in percent) of Rwanda in 1987 to that in 1991?
Offer a very short reply. 1. What is the ratio of the Emissions(in percent) of Antigua and Barbuda in 1987 to that in 1992?
Make the answer very short. 1. What is the ratio of the Emissions(in percent) in Jordan in 1987 to that in 1992?
Offer a terse response. 1.04. What is the ratio of the Emissions(in percent) in Low income in 1987 to that in 1993?
Your answer should be compact. 0.98. What is the ratio of the Emissions(in percent) of Jordan in 1987 to that in 1993?
Your answer should be very brief. 1.06. What is the ratio of the Emissions(in percent) in Rwanda in 1987 to that in 1993?
Your answer should be compact. 1.01. What is the ratio of the Emissions(in percent) in Antigua and Barbuda in 1988 to that in 1989?
Ensure brevity in your answer.  1. What is the ratio of the Emissions(in percent) in Rwanda in 1988 to that in 1989?
Ensure brevity in your answer.  1.01. What is the ratio of the Emissions(in percent) of Low income in 1988 to that in 1990?
Keep it short and to the point. 1.01. What is the ratio of the Emissions(in percent) of Antigua and Barbuda in 1988 to that in 1990?
Your answer should be very brief. 1. What is the ratio of the Emissions(in percent) of Jordan in 1988 to that in 1990?
Ensure brevity in your answer.  0.99. What is the ratio of the Emissions(in percent) of Rwanda in 1988 to that in 1990?
Give a very brief answer. 1.02. What is the ratio of the Emissions(in percent) of Low income in 1988 to that in 1991?
Provide a succinct answer. 0.98. What is the ratio of the Emissions(in percent) of Antigua and Barbuda in 1988 to that in 1991?
Keep it short and to the point. 1. What is the ratio of the Emissions(in percent) of Jordan in 1988 to that in 1991?
Make the answer very short. 0.97. What is the ratio of the Emissions(in percent) in Rwanda in 1988 to that in 1991?
Keep it short and to the point. 1.02. What is the ratio of the Emissions(in percent) of Low income in 1988 to that in 1992?
Your response must be concise. 1.01. What is the ratio of the Emissions(in percent) of Jordan in 1988 to that in 1992?
Give a very brief answer. 1.06. What is the ratio of the Emissions(in percent) in Rwanda in 1988 to that in 1992?
Offer a terse response. 1.02. What is the ratio of the Emissions(in percent) in Low income in 1988 to that in 1993?
Offer a terse response. 0.98. What is the ratio of the Emissions(in percent) of Antigua and Barbuda in 1988 to that in 1993?
Your response must be concise. 1. What is the ratio of the Emissions(in percent) in Jordan in 1988 to that in 1993?
Offer a very short reply. 1.08. What is the ratio of the Emissions(in percent) in Rwanda in 1988 to that in 1993?
Keep it short and to the point. 1.03. What is the ratio of the Emissions(in percent) in Low income in 1989 to that in 1990?
Give a very brief answer. 1.01. What is the ratio of the Emissions(in percent) in Jordan in 1989 to that in 1990?
Keep it short and to the point. 0.98. What is the ratio of the Emissions(in percent) in Rwanda in 1989 to that in 1990?
Offer a terse response. 1.01. What is the ratio of the Emissions(in percent) of Jordan in 1989 to that in 1991?
Give a very brief answer. 0.96. What is the ratio of the Emissions(in percent) of Rwanda in 1989 to that in 1991?
Your answer should be very brief. 1.01. What is the ratio of the Emissions(in percent) in Low income in 1989 to that in 1992?
Keep it short and to the point. 1.01. What is the ratio of the Emissions(in percent) of Jordan in 1989 to that in 1992?
Keep it short and to the point. 1.05. What is the ratio of the Emissions(in percent) of Rwanda in 1989 to that in 1992?
Provide a succinct answer. 1.01. What is the ratio of the Emissions(in percent) in Low income in 1989 to that in 1993?
Provide a short and direct response. 0.99. What is the ratio of the Emissions(in percent) of Jordan in 1989 to that in 1993?
Your answer should be compact. 1.08. What is the ratio of the Emissions(in percent) in Rwanda in 1989 to that in 1993?
Make the answer very short. 1.01. What is the ratio of the Emissions(in percent) of Low income in 1990 to that in 1991?
Offer a very short reply. 0.97. What is the ratio of the Emissions(in percent) of Antigua and Barbuda in 1990 to that in 1991?
Your answer should be very brief. 1. What is the ratio of the Emissions(in percent) of Jordan in 1990 to that in 1991?
Offer a terse response. 0.98. What is the ratio of the Emissions(in percent) of Rwanda in 1990 to that in 1991?
Offer a very short reply. 1. What is the ratio of the Emissions(in percent) of Antigua and Barbuda in 1990 to that in 1992?
Keep it short and to the point. 1. What is the ratio of the Emissions(in percent) in Jordan in 1990 to that in 1992?
Offer a terse response. 1.07. What is the ratio of the Emissions(in percent) in Low income in 1990 to that in 1993?
Keep it short and to the point. 0.97. What is the ratio of the Emissions(in percent) in Antigua and Barbuda in 1990 to that in 1993?
Keep it short and to the point. 1. What is the ratio of the Emissions(in percent) of Jordan in 1990 to that in 1993?
Make the answer very short. 1.1. What is the ratio of the Emissions(in percent) of Low income in 1991 to that in 1992?
Give a very brief answer. 1.03. What is the ratio of the Emissions(in percent) of Jordan in 1991 to that in 1992?
Give a very brief answer. 1.09. What is the ratio of the Emissions(in percent) in Rwanda in 1991 to that in 1992?
Make the answer very short. 1. What is the ratio of the Emissions(in percent) of Low income in 1991 to that in 1993?
Offer a terse response. 1. What is the ratio of the Emissions(in percent) of Antigua and Barbuda in 1991 to that in 1993?
Offer a very short reply. 1. What is the ratio of the Emissions(in percent) in Jordan in 1991 to that in 1993?
Keep it short and to the point. 1.12. What is the ratio of the Emissions(in percent) in Rwanda in 1991 to that in 1993?
Provide a succinct answer. 1.01. What is the ratio of the Emissions(in percent) in Low income in 1992 to that in 1993?
Your response must be concise. 0.98. What is the ratio of the Emissions(in percent) of Jordan in 1992 to that in 1993?
Offer a very short reply. 1.03. What is the ratio of the Emissions(in percent) in Rwanda in 1992 to that in 1993?
Your answer should be compact. 1.01. What is the difference between the highest and the second highest Emissions(in percent) of Low income?
Offer a very short reply. 0.07. What is the difference between the highest and the second highest Emissions(in percent) of Antigua and Barbuda?
Ensure brevity in your answer.  0. What is the difference between the highest and the second highest Emissions(in percent) in Jordan?
Offer a terse response. 1.82. What is the difference between the highest and the second highest Emissions(in percent) of Rwanda?
Offer a very short reply. 3.6. What is the difference between the highest and the lowest Emissions(in percent) of Low income?
Make the answer very short. 1.73. What is the difference between the highest and the lowest Emissions(in percent) in Jordan?
Offer a terse response. 9.92. What is the difference between the highest and the lowest Emissions(in percent) in Rwanda?
Offer a terse response. 6.05. 